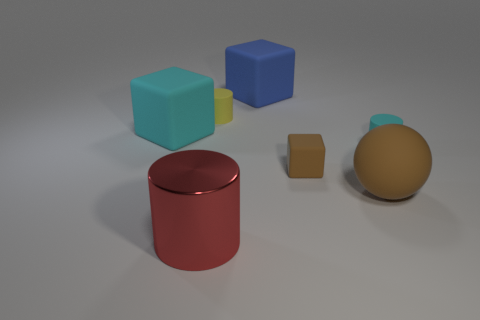Subtract all big cyan rubber blocks. How many blocks are left? 2 Add 1 red metal objects. How many objects exist? 8 Subtract 2 cylinders. How many cylinders are left? 1 Subtract all red cylinders. How many cylinders are left? 2 Subtract all blocks. How many objects are left? 4 Subtract all cyan spheres. How many purple blocks are left? 0 Subtract all tiny cyan cylinders. Subtract all brown rubber blocks. How many objects are left? 5 Add 5 small cyan rubber objects. How many small cyan rubber objects are left? 6 Add 5 big blue cubes. How many big blue cubes exist? 6 Subtract 0 cyan spheres. How many objects are left? 7 